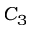<formula> <loc_0><loc_0><loc_500><loc_500>C _ { 3 }</formula> 